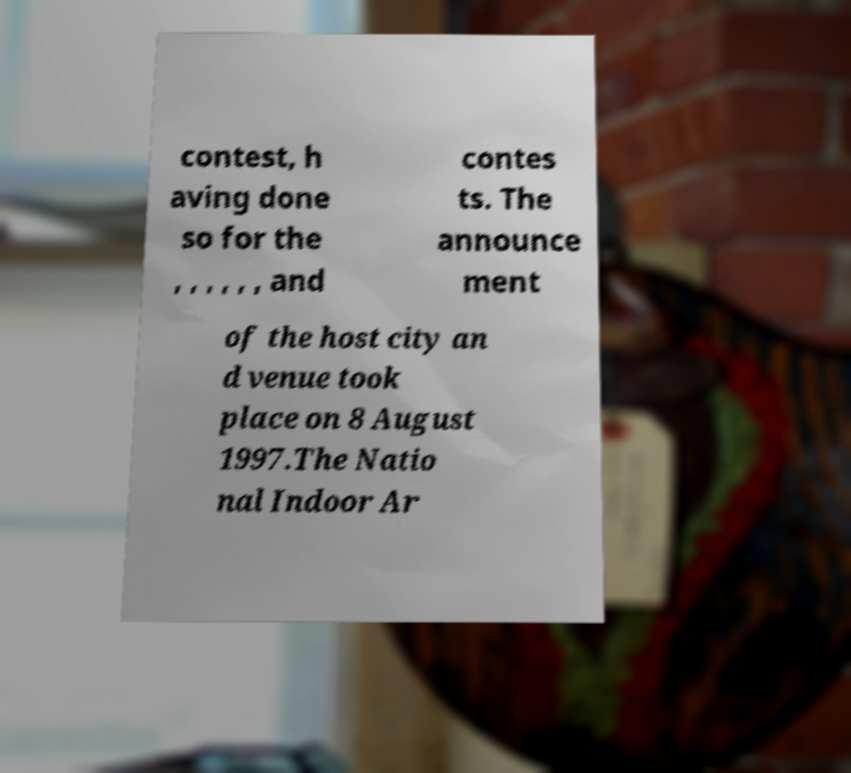Could you extract and type out the text from this image? contest, h aving done so for the , , , , , , and contes ts. The announce ment of the host city an d venue took place on 8 August 1997.The Natio nal Indoor Ar 